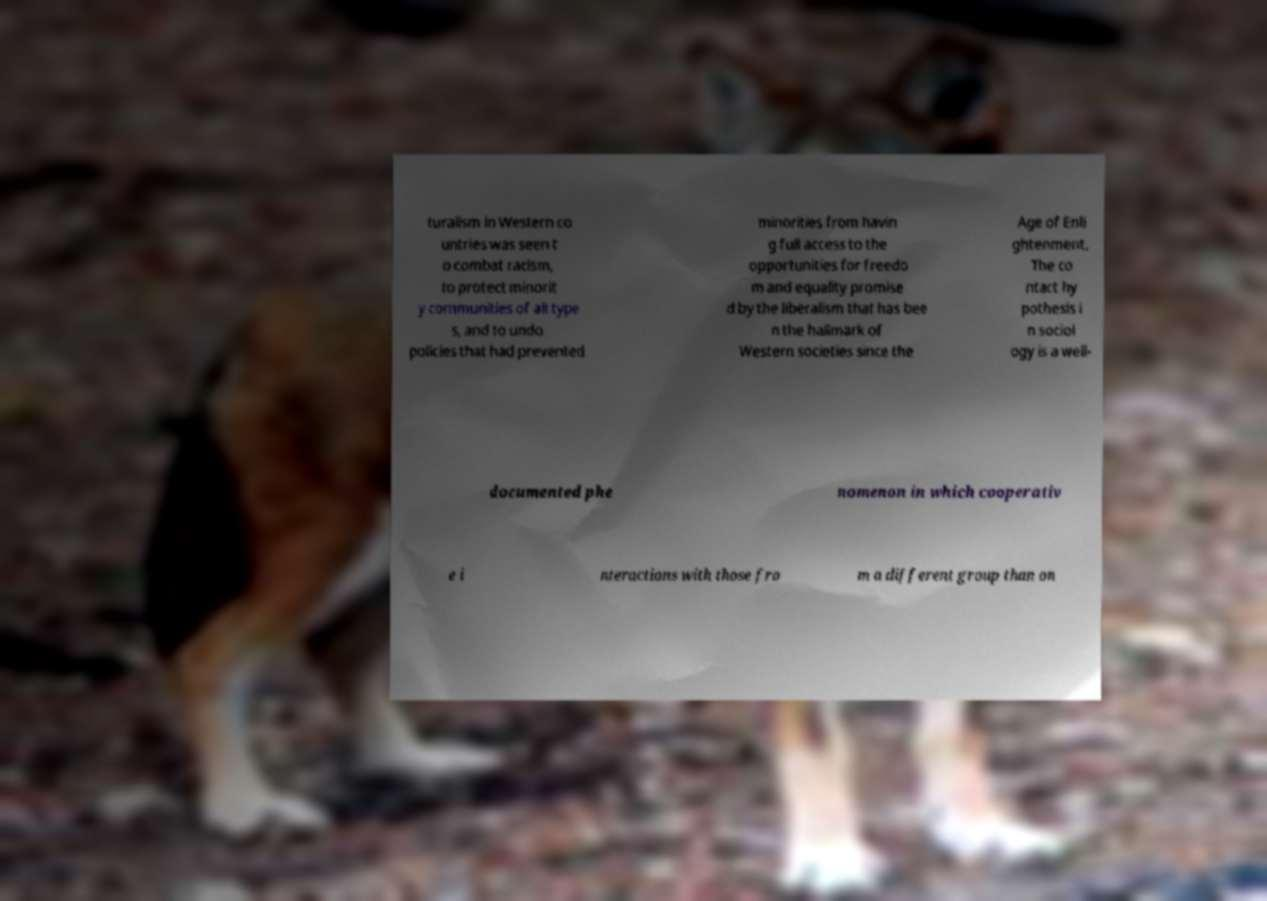There's text embedded in this image that I need extracted. Can you transcribe it verbatim? turalism in Western co untries was seen t o combat racism, to protect minorit y communities of all type s, and to undo policies that had prevented minorities from havin g full access to the opportunities for freedo m and equality promise d by the liberalism that has bee n the hallmark of Western societies since the Age of Enli ghtenment. The co ntact hy pothesis i n sociol ogy is a well- documented phe nomenon in which cooperativ e i nteractions with those fro m a different group than on 